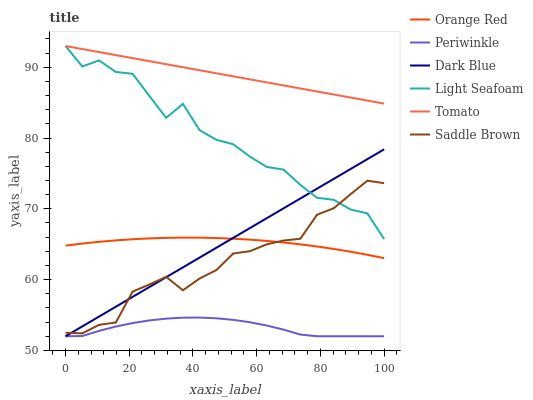Does Periwinkle have the minimum area under the curve?
Answer yes or no. Yes. Does Tomato have the maximum area under the curve?
Answer yes or no. Yes. Does Saddle Brown have the minimum area under the curve?
Answer yes or no. No. Does Saddle Brown have the maximum area under the curve?
Answer yes or no. No. Is Dark Blue the smoothest?
Answer yes or no. Yes. Is Light Seafoam the roughest?
Answer yes or no. Yes. Is Saddle Brown the smoothest?
Answer yes or no. No. Is Saddle Brown the roughest?
Answer yes or no. No. Does Saddle Brown have the lowest value?
Answer yes or no. No. Does Light Seafoam have the highest value?
Answer yes or no. Yes. Does Saddle Brown have the highest value?
Answer yes or no. No. Is Orange Red less than Tomato?
Answer yes or no. Yes. Is Light Seafoam greater than Orange Red?
Answer yes or no. Yes. Does Saddle Brown intersect Light Seafoam?
Answer yes or no. Yes. Is Saddle Brown less than Light Seafoam?
Answer yes or no. No. Is Saddle Brown greater than Light Seafoam?
Answer yes or no. No. Does Orange Red intersect Tomato?
Answer yes or no. No. 